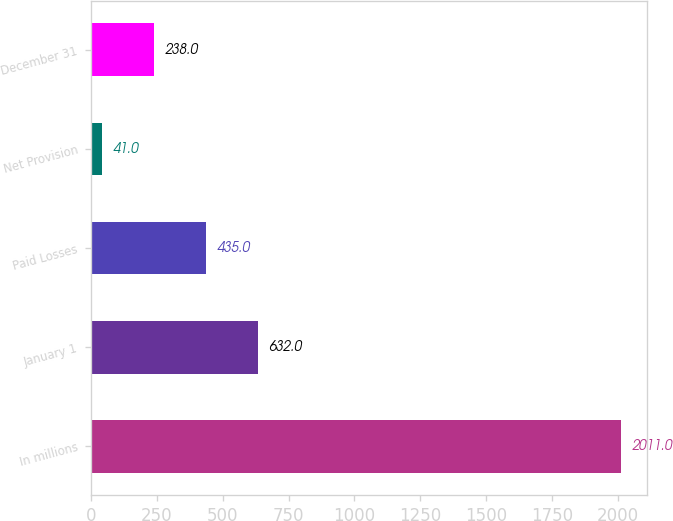Convert chart to OTSL. <chart><loc_0><loc_0><loc_500><loc_500><bar_chart><fcel>In millions<fcel>January 1<fcel>Paid Losses<fcel>Net Provision<fcel>December 31<nl><fcel>2011<fcel>632<fcel>435<fcel>41<fcel>238<nl></chart> 